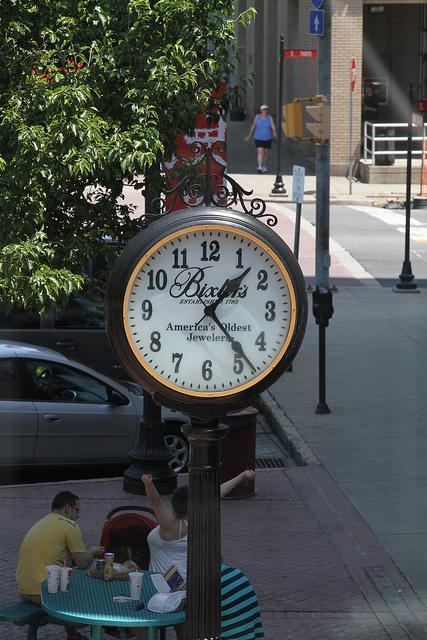How many wheels?
Give a very brief answer. 1. How many clocks are posted?
Give a very brief answer. 1. How many people are visible?
Give a very brief answer. 2. How many plates have a sandwich on it?
Give a very brief answer. 0. 